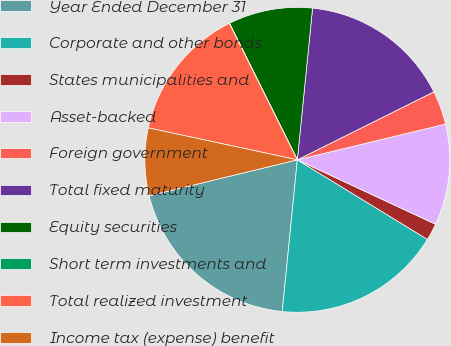Convert chart. <chart><loc_0><loc_0><loc_500><loc_500><pie_chart><fcel>Year Ended December 31<fcel>Corporate and other bonds<fcel>States municipalities and<fcel>Asset-backed<fcel>Foreign government<fcel>Total fixed maturity<fcel>Equity securities<fcel>Short term investments and<fcel>Total realized investment<fcel>Income tax (expense) benefit<nl><fcel>19.63%<fcel>17.84%<fcel>1.8%<fcel>10.71%<fcel>3.58%<fcel>16.06%<fcel>8.93%<fcel>0.02%<fcel>14.28%<fcel>7.15%<nl></chart> 